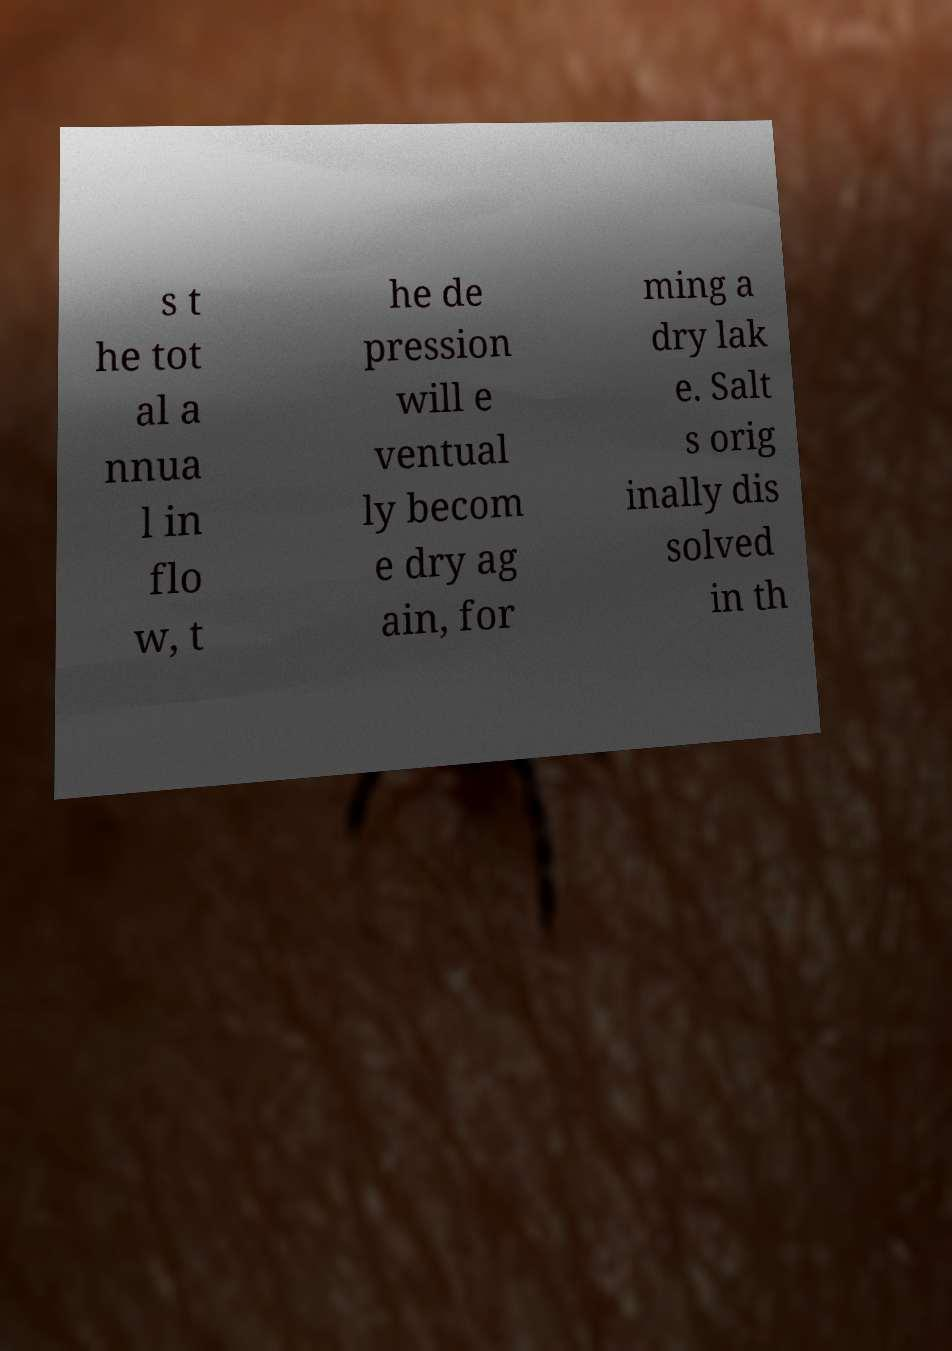I need the written content from this picture converted into text. Can you do that? s t he tot al a nnua l in flo w, t he de pression will e ventual ly becom e dry ag ain, for ming a dry lak e. Salt s orig inally dis solved in th 